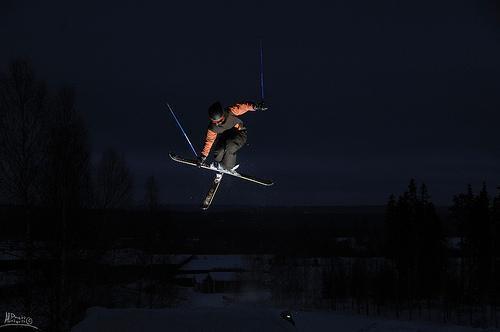How many people are pictured?
Give a very brief answer. 1. 